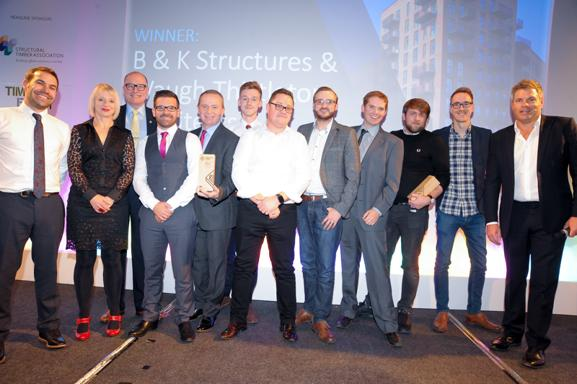Tell me more about the event backdrop. The backdrop features a caption 'WINNER B & K Structures & noughty', along with an urban skyline, implying the event is likely related to achievements in urban development, architecture, or construction. The design is sophisticated, using light colors to create a professional and celebratory ambiance. What might the expressions on their faces tell us? The expressions of joy, pride, and satisfaction on their faces suggest a moment of personal and professional triumph, reflecting the pride in receiving the award and recognition for their hard work and dedication. It captures a moment of collective achievement and personal gratification for the group. 